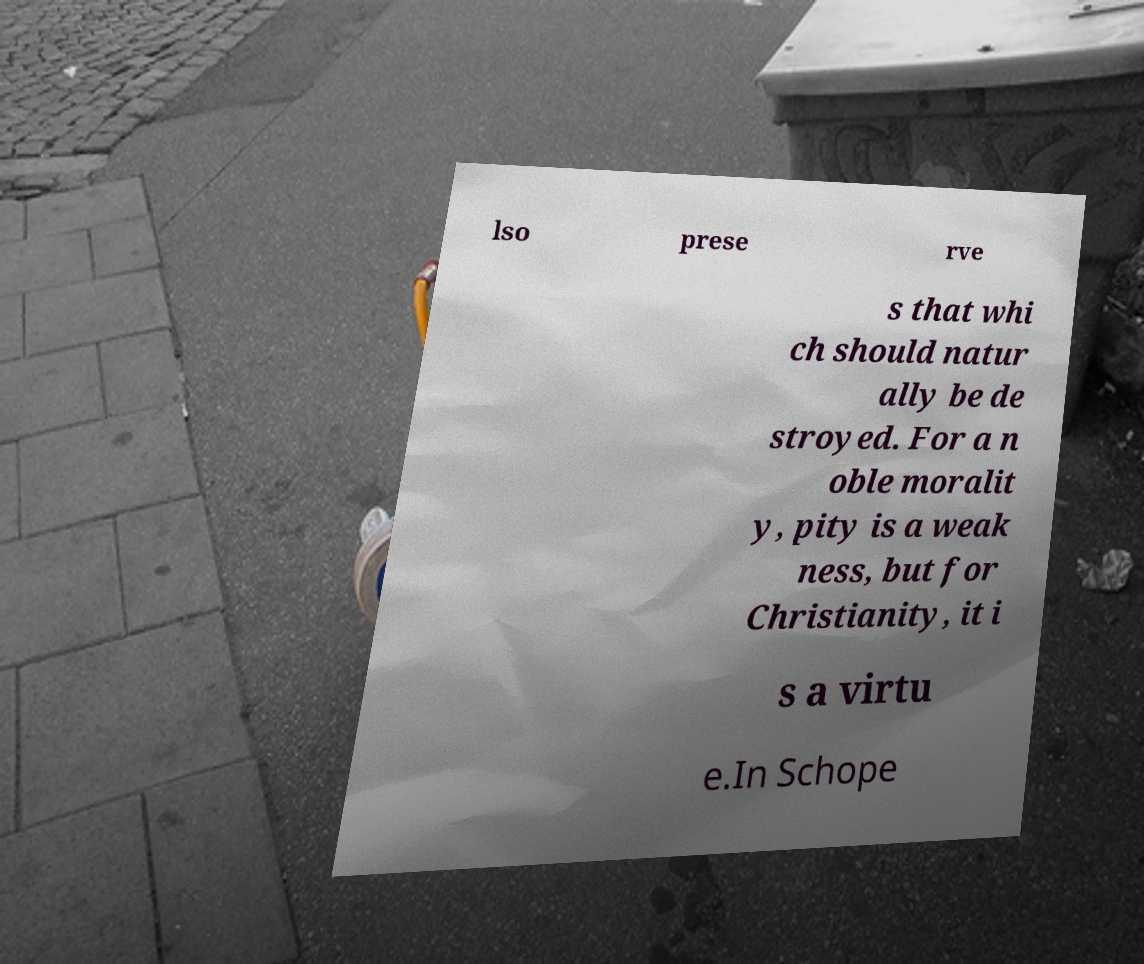Could you extract and type out the text from this image? lso prese rve s that whi ch should natur ally be de stroyed. For a n oble moralit y, pity is a weak ness, but for Christianity, it i s a virtu e.In Schope 